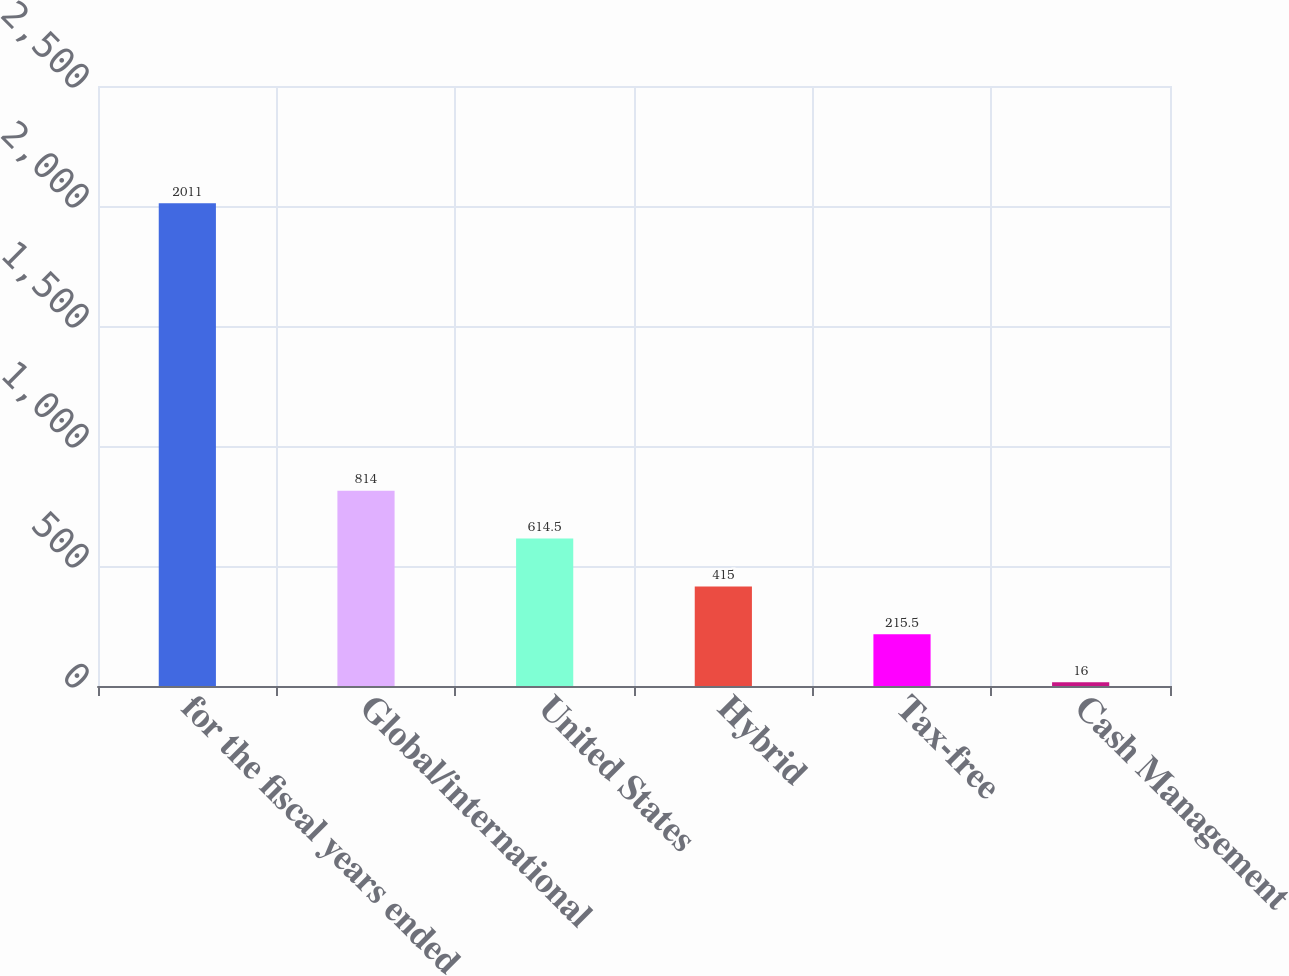<chart> <loc_0><loc_0><loc_500><loc_500><bar_chart><fcel>for the fiscal years ended<fcel>Global/international<fcel>United States<fcel>Hybrid<fcel>Tax-free<fcel>Cash Management<nl><fcel>2011<fcel>814<fcel>614.5<fcel>415<fcel>215.5<fcel>16<nl></chart> 